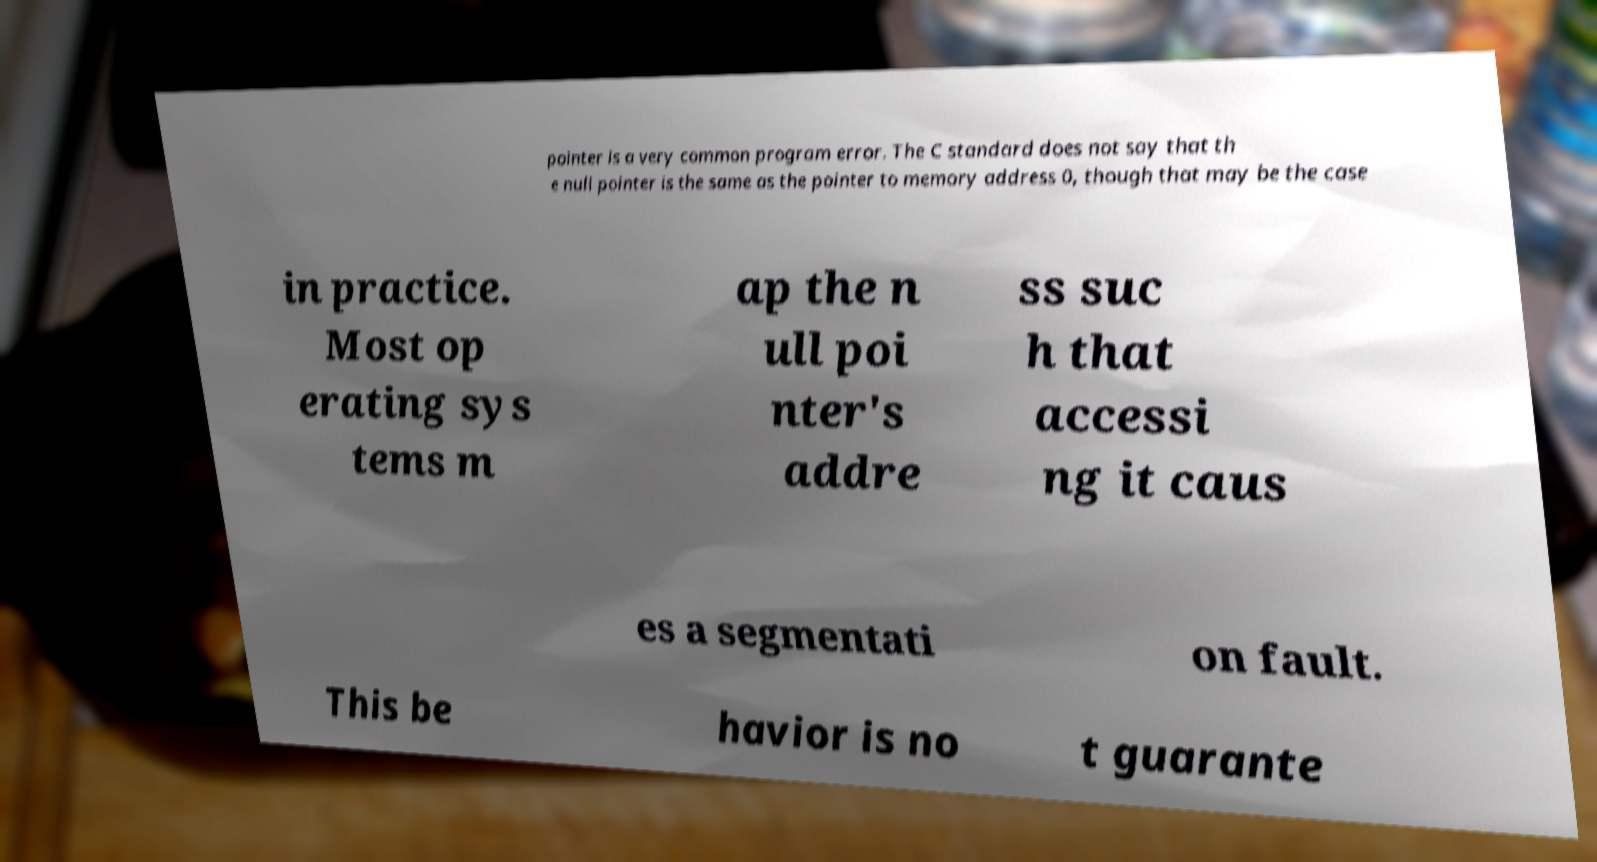Can you read and provide the text displayed in the image?This photo seems to have some interesting text. Can you extract and type it out for me? pointer is a very common program error. The C standard does not say that th e null pointer is the same as the pointer to memory address 0, though that may be the case in practice. Most op erating sys tems m ap the n ull poi nter's addre ss suc h that accessi ng it caus es a segmentati on fault. This be havior is no t guarante 